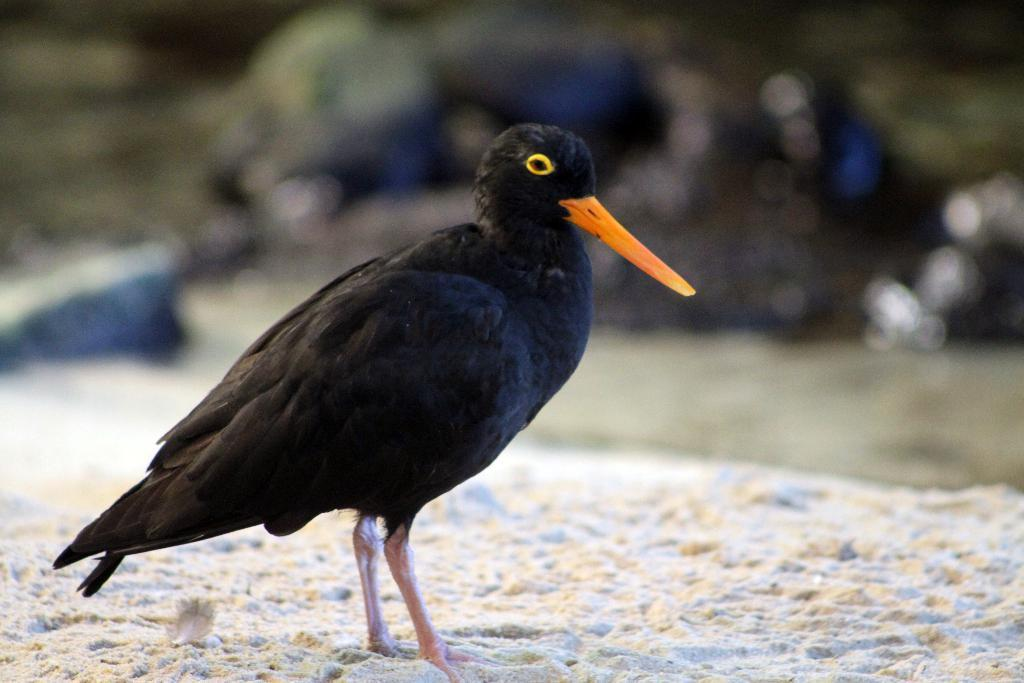What is the main subject of the picture? The main subject of the picture is a black color bird. Can you describe the bird's location in the image? The bird is in the middle of the picture. What can be observed about the background of the image? The background of the image is blurred. How many eggs can be seen under the bird in the image? There are no eggs visible under the bird in the image. What type of shade is covering the bird in the image? There is no shade covering the bird in the image; it is in an open area. 